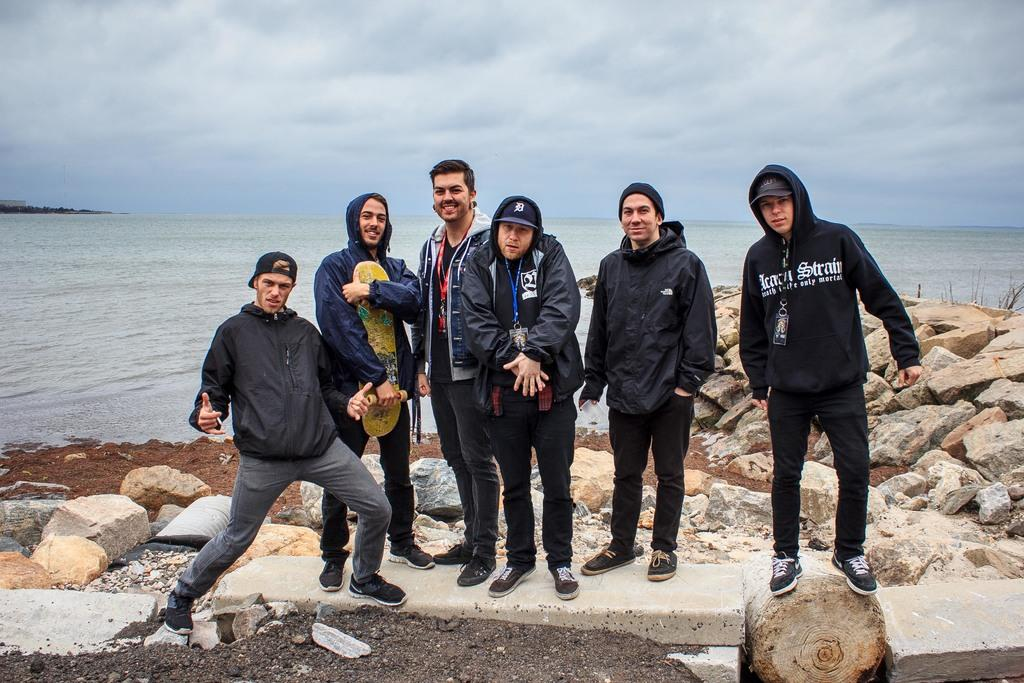What can be seen in the image? There are people standing in the image. What is on the ground in the image? There are rocks and stones on the ground in the image. What is visible in the background of the image? There is a sea visible in the background of the image. What is visible at the top of the image? The sky is visible at the top of the image. What type of bed can be seen in the image? There is no bed present in the image. What plot of land is being farmed in the image? There is no farming or plot of land visible in the image. 